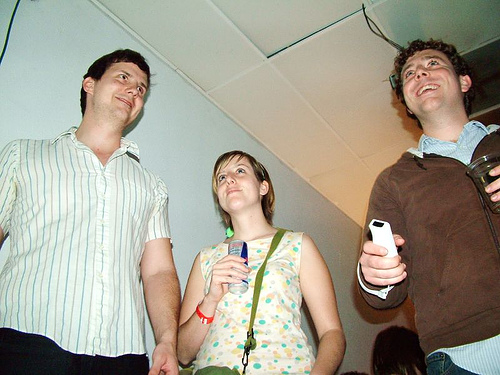<image>Which are has a pink strap? There is no information about a pink strap. The answer is ambiguous. Which are has a pink strap? I don't know which area has a pink strap. It is not clear from the given information. 